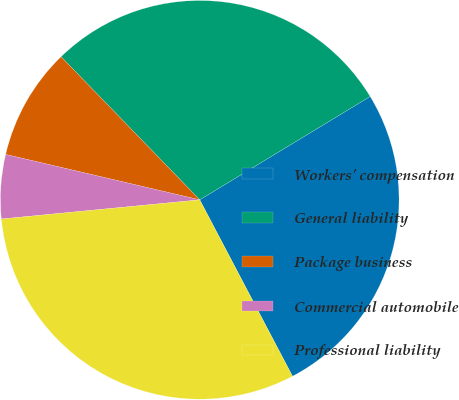<chart> <loc_0><loc_0><loc_500><loc_500><pie_chart><fcel>Workers' compensation<fcel>General liability<fcel>Package business<fcel>Commercial automobile<fcel>Professional liability<nl><fcel>25.97%<fcel>28.57%<fcel>9.09%<fcel>5.19%<fcel>31.17%<nl></chart> 